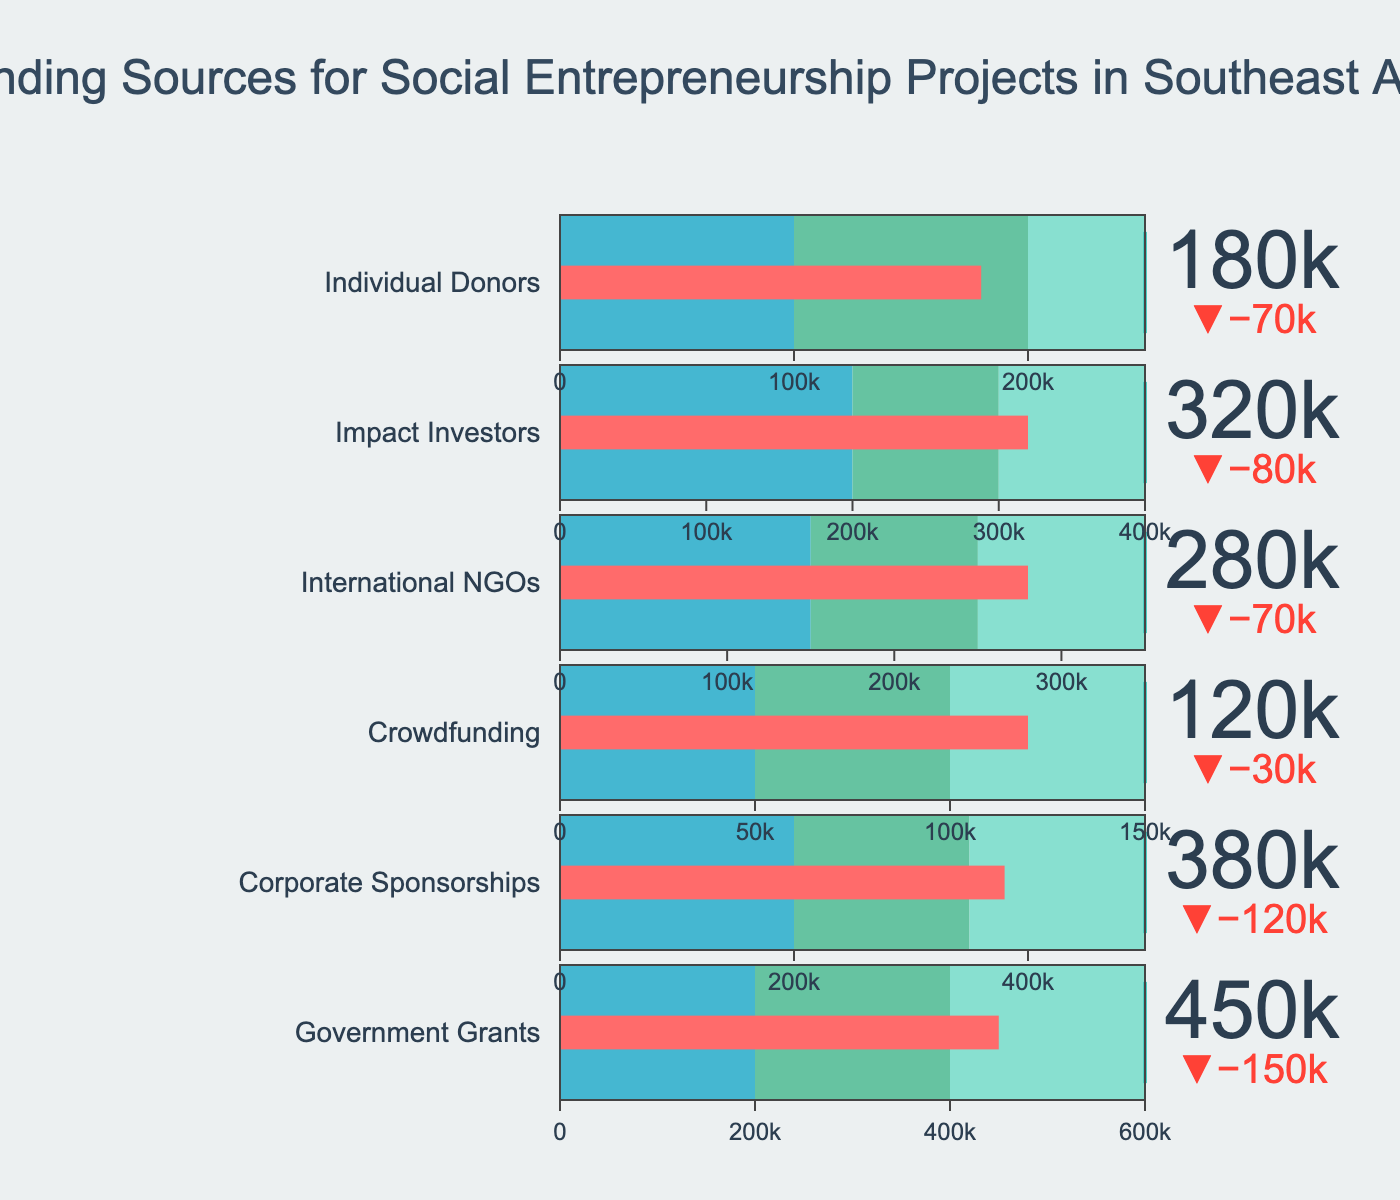what is the title of the plot? The title is located at the top center of the plot and is surrounded by visual elements of the chart. Refer to this space to get the title.
Answer: Funding Sources for Social Entrepreneurship Projects in Southeast Asia What is the actual funding amount from Corporate Sponsorships? Find the corresponding category "Corporate Sponsorships" in the chart and look at the value indicated in the bar.
Answer: 380,000 Which funding source has the highest target value? Compare the target values for all funding sources displayed as the threshold line in each bullet and find out which one is the highest.
Answer: Government Grants What is the difference between the actual and target values for International NGOs? Find the actual value and target value for International NGOs and calculate their difference. 280,000 - 350,000 = -70,000
Answer: -70,000 How many funding sources have an actual funding amount greater than their range2 value? Determine the range2 value for each funding source and compare it with the actual funding amount. Count how many actual funding amounts exceed their range2 value.
Answer: Four Which category has the smallest difference between its actual and target value? Calculate the difference between the actual and target values for each category to identify which one is the smallest.
Answer: Individual Donors What is the total actual funding amount from all sources? Sum up the actual values for all the funding sources. 450,000 + 380,000 + 120,000 + 280,000 + 320,000 + 180,000 = 1,730,000
Answer: 1,730,000 Which funding source is closest to meeting its target? Compare the actual values to the target values and determine which one is closest to achieving its target.
Answer: Corporate Sponsorships What are the ranges of funding for Crowdfunding from low to high? Identify the range values for Crowdfunding, ordered from low to high: 50,000, 100,000, 150,000.
Answer: 50,000, 100,000, 150,000 How many categories have an actual value below their range1 value? Check each category's actual value and compare it with its range1 value. Count how many are below their range1 value.
Answer: None 